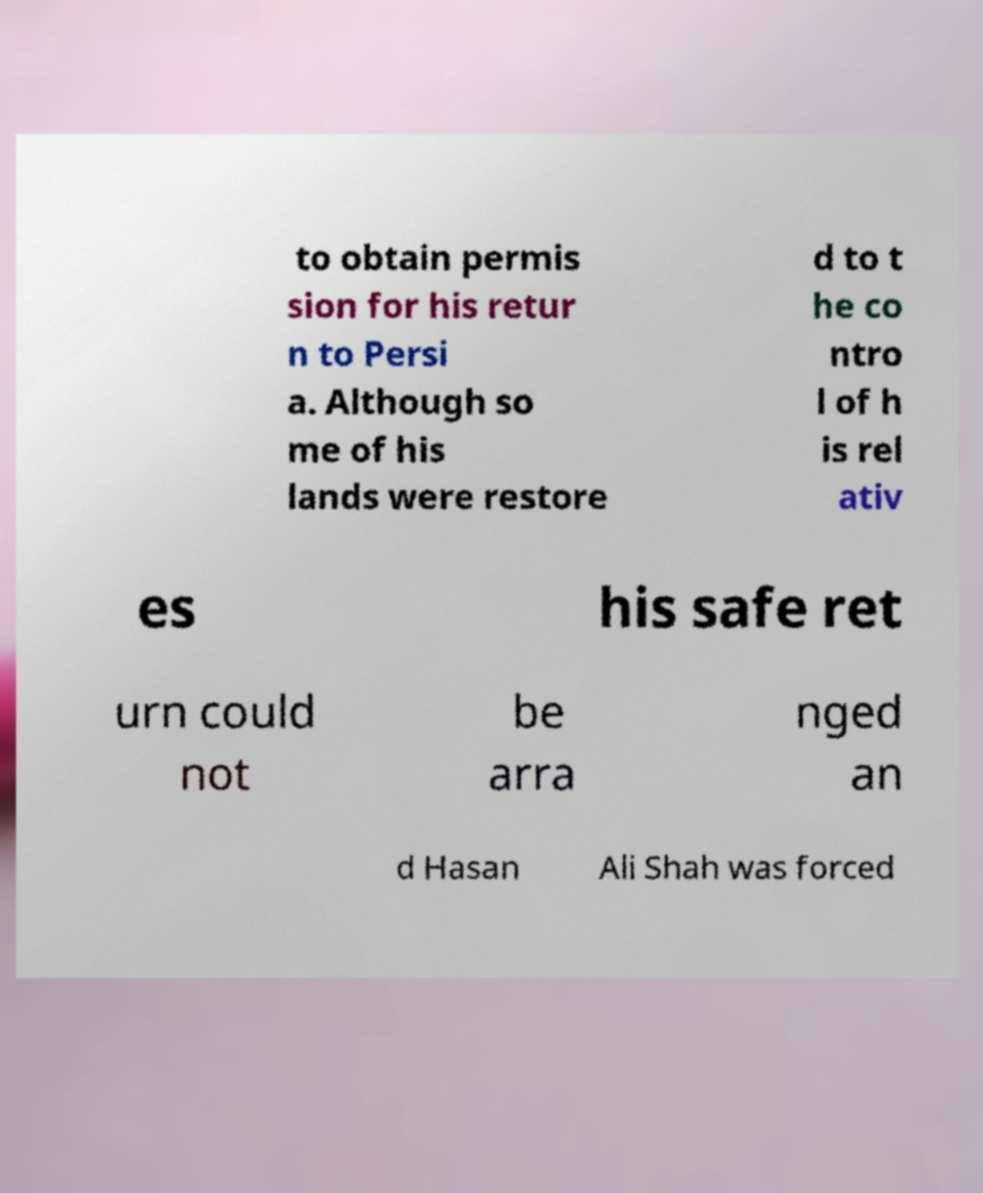Can you accurately transcribe the text from the provided image for me? to obtain permis sion for his retur n to Persi a. Although so me of his lands were restore d to t he co ntro l of h is rel ativ es his safe ret urn could not be arra nged an d Hasan Ali Shah was forced 